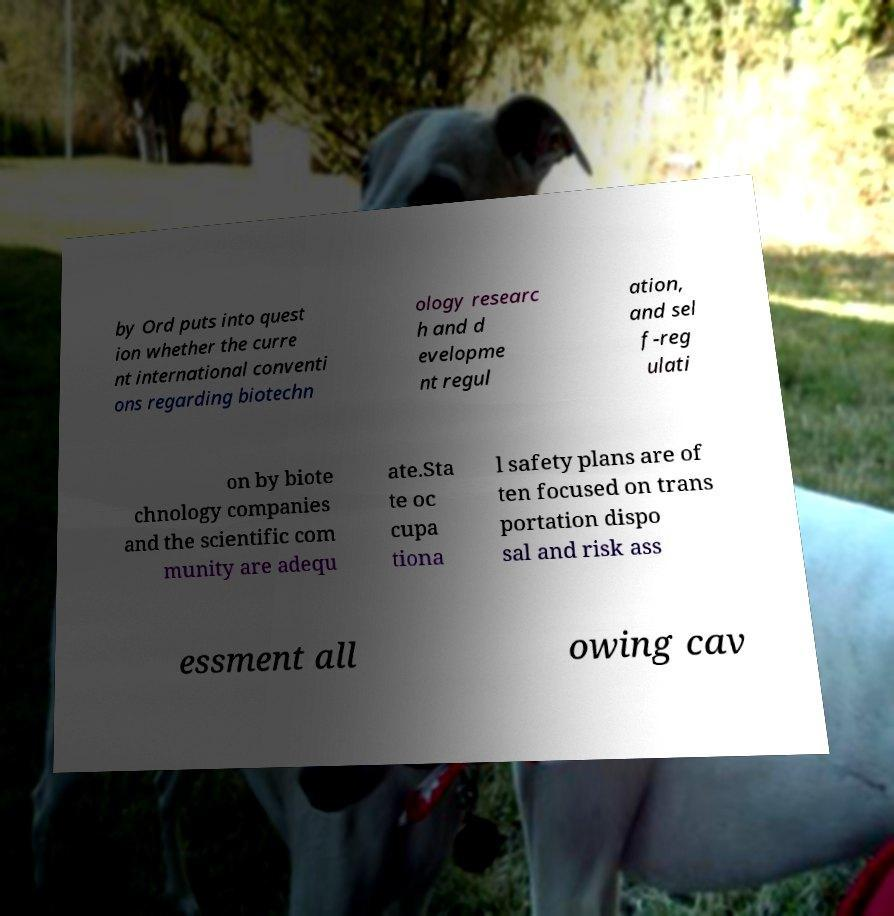What messages or text are displayed in this image? I need them in a readable, typed format. by Ord puts into quest ion whether the curre nt international conventi ons regarding biotechn ology researc h and d evelopme nt regul ation, and sel f-reg ulati on by biote chnology companies and the scientific com munity are adequ ate.Sta te oc cupa tiona l safety plans are of ten focused on trans portation dispo sal and risk ass essment all owing cav 